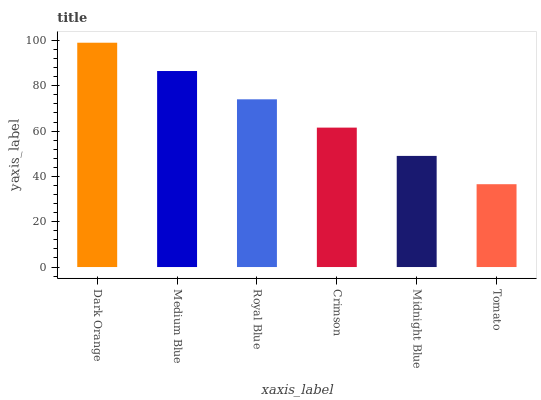Is Tomato the minimum?
Answer yes or no. Yes. Is Dark Orange the maximum?
Answer yes or no. Yes. Is Medium Blue the minimum?
Answer yes or no. No. Is Medium Blue the maximum?
Answer yes or no. No. Is Dark Orange greater than Medium Blue?
Answer yes or no. Yes. Is Medium Blue less than Dark Orange?
Answer yes or no. Yes. Is Medium Blue greater than Dark Orange?
Answer yes or no. No. Is Dark Orange less than Medium Blue?
Answer yes or no. No. Is Royal Blue the high median?
Answer yes or no. Yes. Is Crimson the low median?
Answer yes or no. Yes. Is Medium Blue the high median?
Answer yes or no. No. Is Medium Blue the low median?
Answer yes or no. No. 